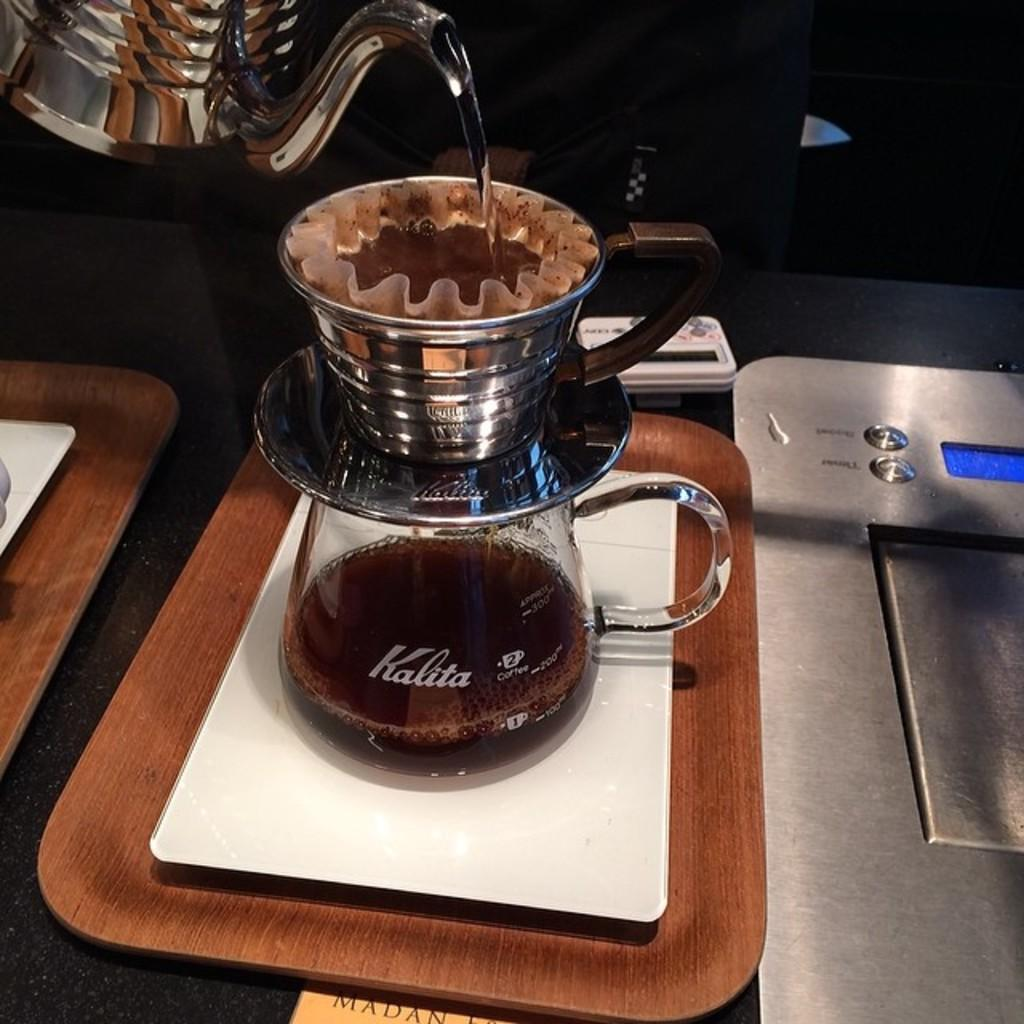<image>
Create a compact narrative representing the image presented. the water is added to the coffee powder to get a filter coffee and  stores in a bottle which named as kalita. 